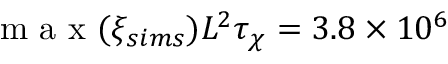Convert formula to latex. <formula><loc_0><loc_0><loc_500><loc_500>m a x ( \xi _ { s i m s } ) L ^ { 2 } \tau _ { \chi } = 3 . 8 \times 1 0 ^ { 6 }</formula> 